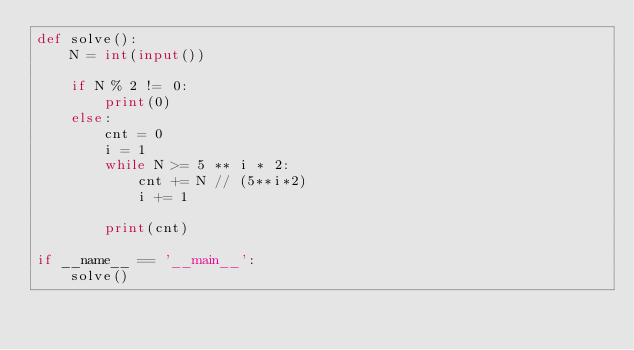<code> <loc_0><loc_0><loc_500><loc_500><_Python_>def solve():
    N = int(input())

    if N % 2 != 0:
        print(0)
    else:
        cnt = 0
        i = 1
        while N >= 5 ** i * 2:
            cnt += N // (5**i*2)
            i += 1
    
        print(cnt)

if __name__ == '__main__':
    solve()</code> 